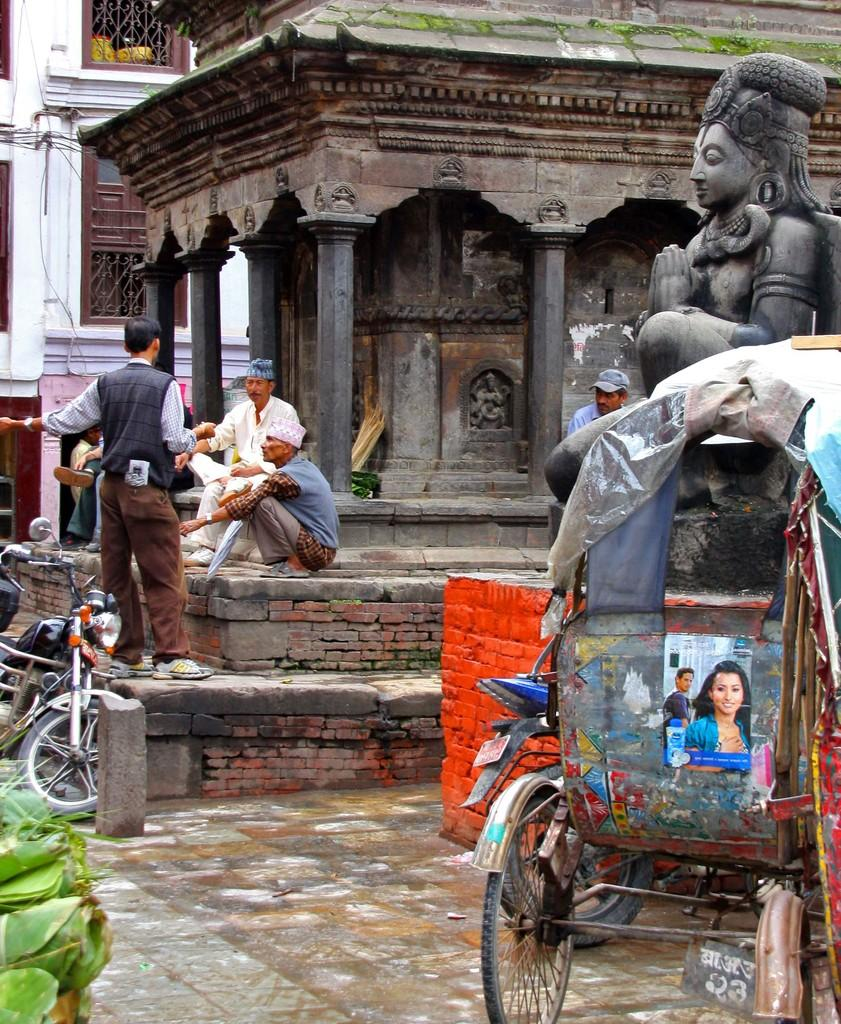What type of structures can be seen in the image? There are buildings in the image. What objects are present for cooking in the image? There are grills in the image. What type of artistic objects are in the image? There are statues in the image. What are the people in the image doing? There are persons sitting on the pavement in the image. What mode of transportation is present in the image? There are motor vehicles in the image. What type of natural elements can be seen in the image? There are leaves in the image. What surface is visible in the image? There is a floor visible in the image. What type of vehicle is present in the image? There is a rickshaw in the image. Where is the icicle hanging in the image? There is no icicle present in the image. What type of sign is visible in the image? There is no sign visible in the image. What type of fuel is being used by the motor vehicles in the image? The image does not provide information about the type of fuel being used by the motor vehicles. 